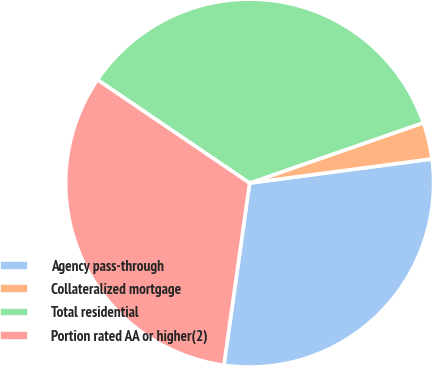<chart> <loc_0><loc_0><loc_500><loc_500><pie_chart><fcel>Agency pass-through<fcel>Collateralized mortgage<fcel>Total residential<fcel>Portion rated AA or higher(2)<nl><fcel>29.33%<fcel>3.22%<fcel>35.19%<fcel>32.26%<nl></chart> 